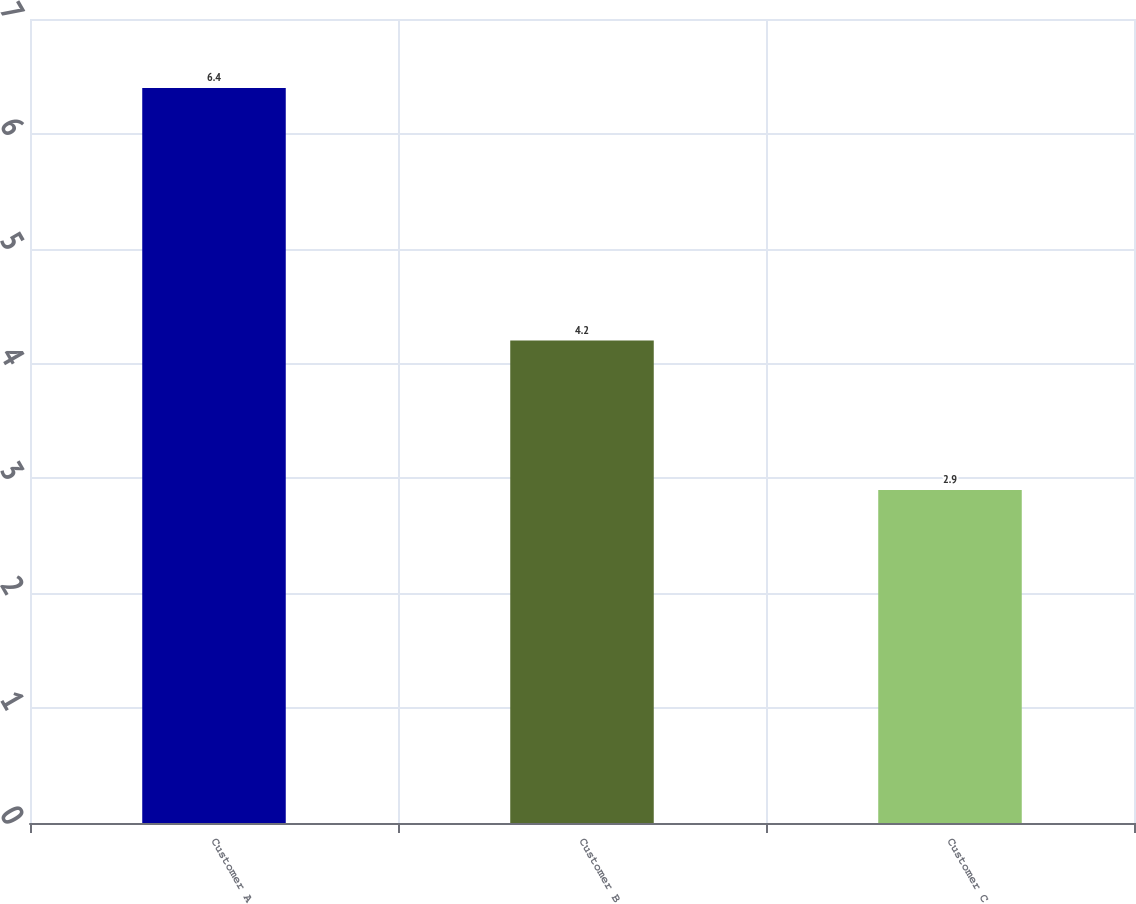Convert chart to OTSL. <chart><loc_0><loc_0><loc_500><loc_500><bar_chart><fcel>Customer A<fcel>Customer B<fcel>Customer C<nl><fcel>6.4<fcel>4.2<fcel>2.9<nl></chart> 